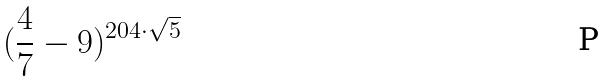<formula> <loc_0><loc_0><loc_500><loc_500>( \frac { 4 } { 7 } - 9 ) ^ { 2 0 4 \cdot \sqrt { 5 } }</formula> 